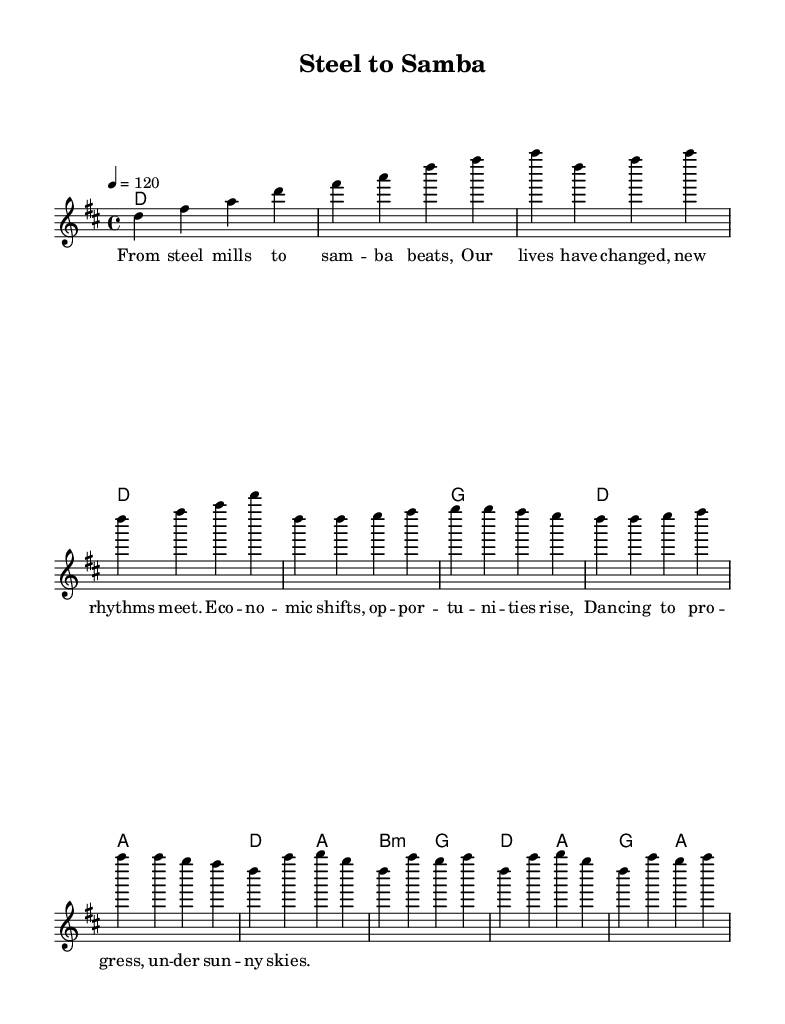What is the key signature of this music? The key signature is D major, indicated by two sharps (F# and C#). This can be determined by examining the key signature at the beginning of the score, which shows those two sharps.
Answer: D major What is the time signature of this music? The time signature is 4/4, indicated at the beginning of the score. This means there are four beats per measure, and each quarter note receives one beat.
Answer: 4/4 What is the tempo marking of the piece? The tempo marking is 120, indicating how many beats per minute the piece should be played. This is specified after the tempo indication “4 =” in the score.
Answer: 120 How many measures are in the introductory section? The introductory section contains four measures, as shown by the grouping of the notes before the verse starts. A count of the measures reveals that all four have distinct melodies.
Answer: 4 What is the primary theme explored in the lyrics? The primary theme explored in the lyrics is economic shifts and social mobility, illustrated through the imagery of transitioning from steel mills to samba beats, reflecting change and progress in society. This theme is encapsulated in the words describing the combination of traditional work and new rhythms.
Answer: Economic shifts and social mobility Which chord occurs most frequently in the verse section? The most frequently occurring chord in the verse section is D major, as it appears at the beginning of the verse and the following measures, highlighting its significance in the musical structure.
Answer: D major What musical genre does this piece best represent? This piece best represents samba-rock, characterized by its fusion of traditional Brazilian samba rhythms with rock influences, as reflected in both the musical elements and the lyrics.
Answer: Samba-rock 